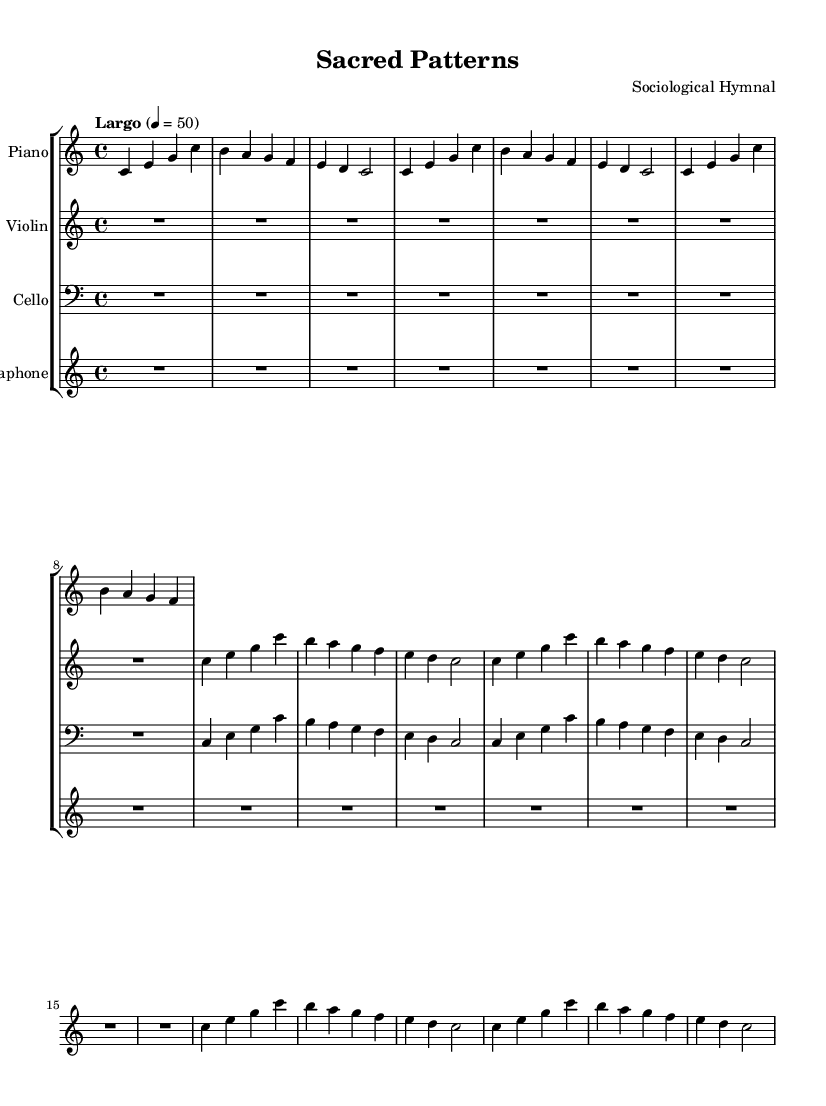What is the key signature of this music? The key signature is C major, which has no sharps or flats.
Answer: C major What is the time signature of this music? The time signature is indicated as 4/4, which means there are four beats in each measure.
Answer: 4/4 What is the tempo marking for this composition? The tempo marking is "Largo," indicating a slow tempo, which is reflected in the marking being set at 50 beats per minute.
Answer: Largo How many instruments are included in this piece? There are four instruments listed: Piano, Violin, Cello, and Vibraphone.
Answer: Four Which instruments are playing the same melodic patterns? The Piano, Violin, and Cello all play the same melodic patterns in the first few measures, reflecting a cohesive structure.
Answer: Piano, Violin, Cello What is the first note played by the Vibraphone? The first note played by the Vibraphone is C, which starts the pattern in the score.
Answer: C Are there any rests in this piece, and if so, how long are they? There are rests, specifically one whole note rest at the beginning for the Violin and Cello, followed by smaller rests in the Vibraphone part.
Answer: One whole note rest 